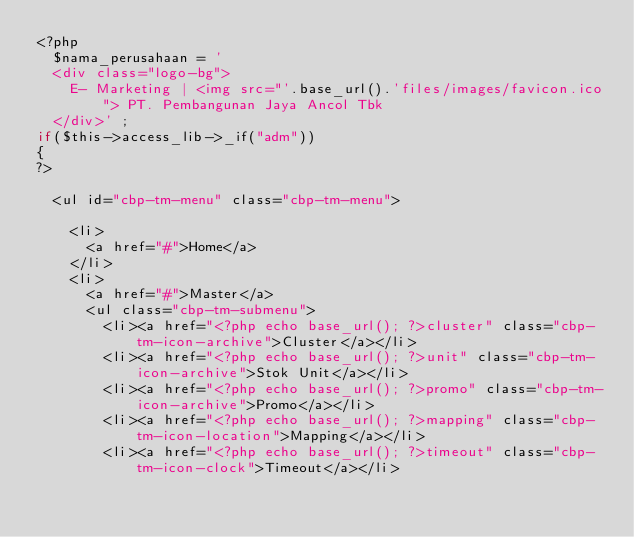Convert code to text. <code><loc_0><loc_0><loc_500><loc_500><_PHP_><?php
	$nama_perusahaan = '
	<div class="logo-bg">
		E- Marketing | <img src="'.base_url().'files/images/favicon.ico"> PT. Pembangunan Jaya Ancol Tbk
	</div>' ;
if($this->access_lib->_if("adm"))
{
?>

	<ul id="cbp-tm-menu" class="cbp-tm-menu">
		
		<li>
			<a href="#">Home</a>
		</li>
		<li>
			<a href="#">Master</a>
			<ul class="cbp-tm-submenu">
				<li><a href="<?php echo base_url(); ?>cluster" class="cbp-tm-icon-archive">Cluster</a></li>
				<li><a href="<?php echo base_url(); ?>unit" class="cbp-tm-icon-archive">Stok Unit</a></li>
				<li><a href="<?php echo base_url(); ?>promo" class="cbp-tm-icon-archive">Promo</a></li>
				<li><a href="<?php echo base_url(); ?>mapping" class="cbp-tm-icon-location">Mapping</a></li>
				<li><a href="<?php echo base_url(); ?>timeout" class="cbp-tm-icon-clock">Timeout</a></li></code> 